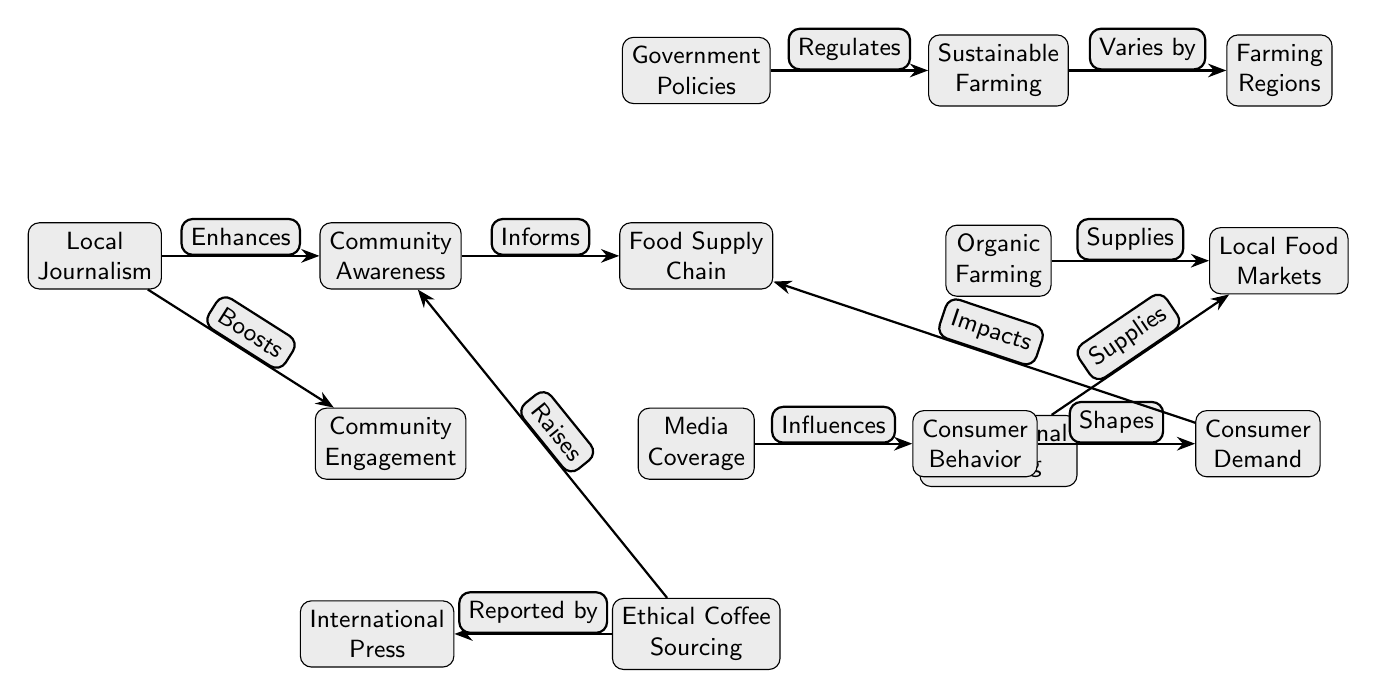What effect does local journalism have on community awareness? The diagram shows that local journalism enhances community awareness by connecting directly to that node.
Answer: Enhances How many total nodes are in the diagram? By counting the nodes in the diagram, we identify a total of 13 separate nodes including Local Journalism, Community Awareness, Food Supply Chain, etc.
Answer: 13 What does sustainable farming vary by? The connection shows that sustainable farming varies by the farming region as indicated in the diagram.
Answer: Farming Regions Which node influences consumer behavior? Media coverage has a direct edge that influences consumer behavior, according to the diagram.
Answer: Media Coverage What role do government policies play in farming practices? The diagram indicates that government policies regulate sustainable farming, establishing a direct link between the two nodes.
Answer: Regulates What does organic farming supply? The organic farming node supplies local food markets as shown in the diagram.
Answer: Local Food Markets How does ethical coffee sourcing relate to international press? Ethical coffee sourcing is reported by international press, which is explicitly indicated by the diagram connection.
Answer: Reported by What is the connection between consumer behavior and consumer demand? Consumer behavior shapes consumer demand, showcasing a direct influence as shown by the arrow in the diagram.
Answer: Shapes What is the effect of media coverage on the food supply chain? The diagram illustrates that consumer demand impacts the food supply chain, indicating a pathway from media coverage to that node indirectly through consumer behavior.
Answer: Impacts What enhances community engagement? Local journalism boosts community engagement, as depicted in the diagram with a direct connection.
Answer: Boosts 